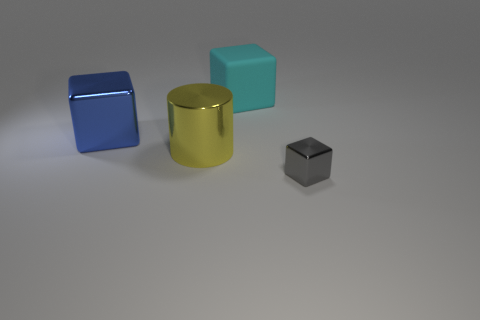What number of large things are both in front of the large blue thing and to the right of the yellow shiny cylinder?
Your answer should be compact. 0. There is a cyan block that is the same size as the yellow metallic thing; what is it made of?
Offer a terse response. Rubber. Do the metallic object that is to the right of the yellow cylinder and the metallic cube to the left of the small gray metallic thing have the same size?
Your answer should be very brief. No. Are there any large things behind the big cyan object?
Your answer should be very brief. No. There is a block behind the shiny block behind the gray shiny object; what color is it?
Keep it short and to the point. Cyan. Are there fewer metallic cubes than large yellow objects?
Keep it short and to the point. No. What number of other objects have the same shape as the cyan thing?
Provide a short and direct response. 2. What is the color of the metallic block that is the same size as the rubber cube?
Offer a terse response. Blue. Are there the same number of large shiny cylinders to the left of the big yellow cylinder and large objects that are behind the big cyan rubber cube?
Provide a short and direct response. Yes. Are there any objects of the same size as the gray cube?
Your response must be concise. No. 